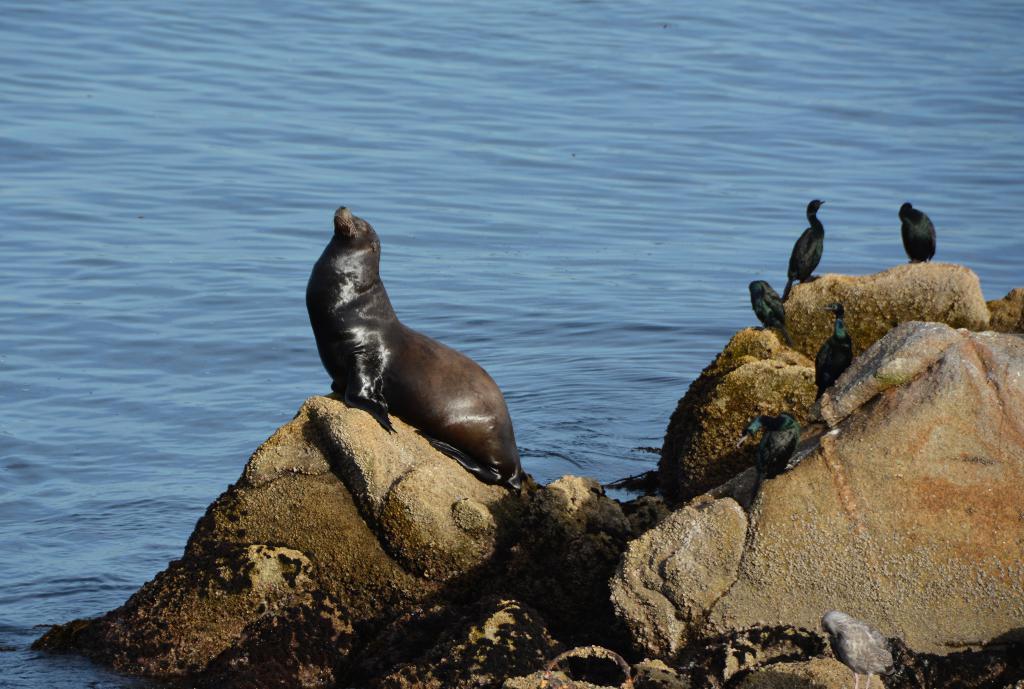How would you summarize this image in a sentence or two? In this image we can see seal and birds on the rocks at the water. 